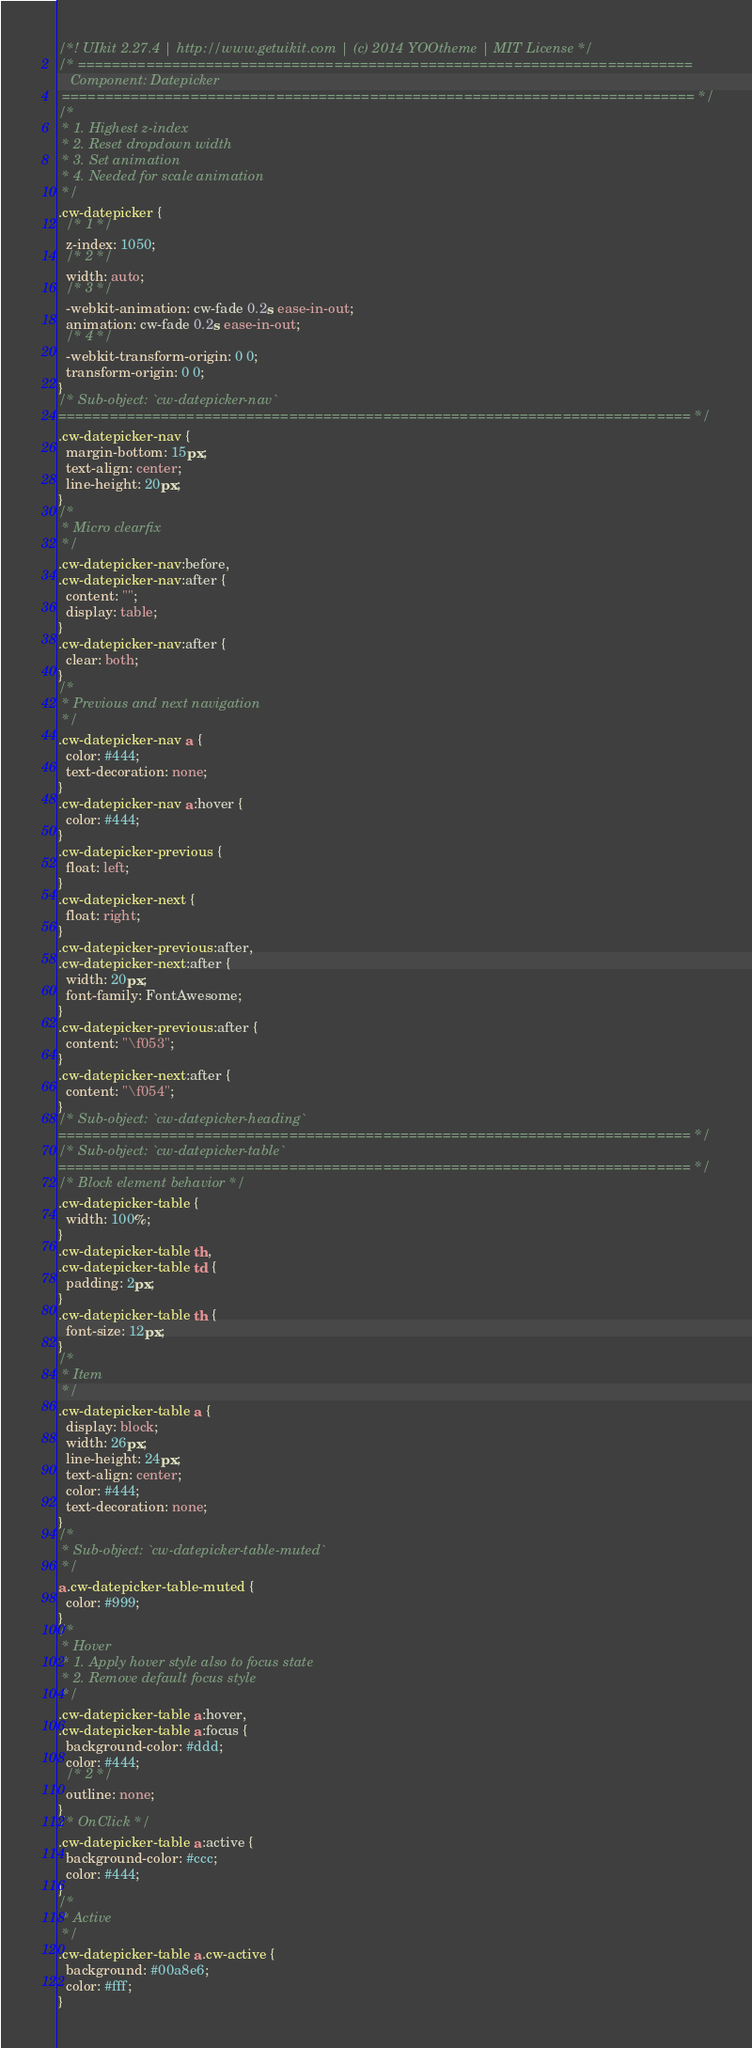Convert code to text. <code><loc_0><loc_0><loc_500><loc_500><_CSS_>/*! UIkit 2.27.4 | http://www.getuikit.com | (c) 2014 YOOtheme | MIT License */
/* ========================================================================
   Component: Datepicker
 ========================================================================== */
/*
 * 1. Highest z-index
 * 2. Reset dropdown width
 * 3. Set animation
 * 4. Needed for scale animation
 */
.cw-datepicker {
  /* 1 */
  z-index: 1050;
  /* 2 */
  width: auto;
  /* 3 */
  -webkit-animation: cw-fade 0.2s ease-in-out;
  animation: cw-fade 0.2s ease-in-out;
  /* 4 */
  -webkit-transform-origin: 0 0;
  transform-origin: 0 0;
}
/* Sub-object: `cw-datepicker-nav`
========================================================================== */
.cw-datepicker-nav {
  margin-bottom: 15px;
  text-align: center;
  line-height: 20px;
}
/*
 * Micro clearfix
 */
.cw-datepicker-nav:before,
.cw-datepicker-nav:after {
  content: "";
  display: table;
}
.cw-datepicker-nav:after {
  clear: both;
}
/*
 * Previous and next navigation
 */
.cw-datepicker-nav a {
  color: #444;
  text-decoration: none;
}
.cw-datepicker-nav a:hover {
  color: #444;
}
.cw-datepicker-previous {
  float: left;
}
.cw-datepicker-next {
  float: right;
}
.cw-datepicker-previous:after,
.cw-datepicker-next:after {
  width: 20px;
  font-family: FontAwesome;
}
.cw-datepicker-previous:after {
  content: "\f053";
}
.cw-datepicker-next:after {
  content: "\f054";
}
/* Sub-object: `cw-datepicker-heading`
========================================================================== */
/* Sub-object: `cw-datepicker-table`
========================================================================== */
/* Block element behavior */
.cw-datepicker-table {
  width: 100%;
}
.cw-datepicker-table th,
.cw-datepicker-table td {
  padding: 2px;
}
.cw-datepicker-table th {
  font-size: 12px;
}
/*
 * Item
 */
.cw-datepicker-table a {
  display: block;
  width: 26px;
  line-height: 24px;
  text-align: center;
  color: #444;
  text-decoration: none;
}
/*
 * Sub-object: `cw-datepicker-table-muted`
 */
a.cw-datepicker-table-muted {
  color: #999;
}
/*
 * Hover
 * 1. Apply hover style also to focus state
 * 2. Remove default focus style
 */
.cw-datepicker-table a:hover,
.cw-datepicker-table a:focus {
  background-color: #ddd;
  color: #444;
  /* 2 */
  outline: none;
}
/* OnClick */
.cw-datepicker-table a:active {
  background-color: #ccc;
  color: #444;
}
/*
 * Active
 */
.cw-datepicker-table a.cw-active {
  background: #00a8e6;
  color: #fff;
}
</code> 